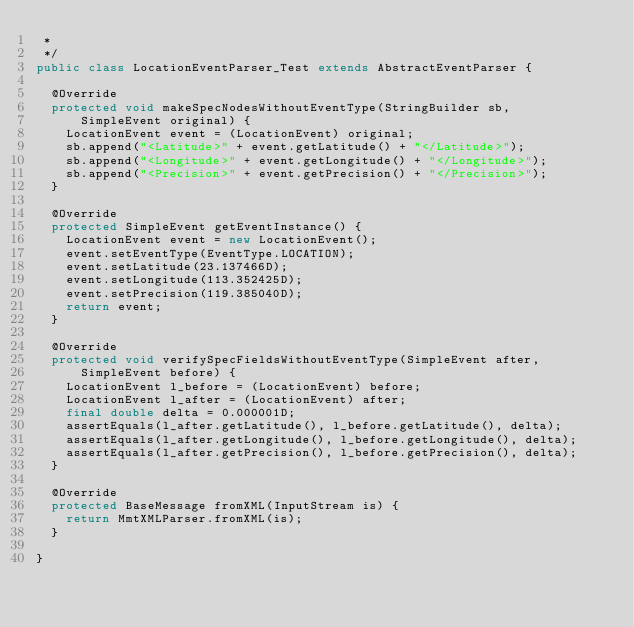<code> <loc_0><loc_0><loc_500><loc_500><_Java_> *
 */
public class LocationEventParser_Test extends AbstractEventParser {

	@Override
	protected void makeSpecNodesWithoutEventType(StringBuilder sb,
			SimpleEvent original) {
		LocationEvent event = (LocationEvent) original;
		sb.append("<Latitude>" + event.getLatitude() + "</Latitude>");
		sb.append("<Longitude>" + event.getLongitude() + "</Longitude>");
		sb.append("<Precision>" + event.getPrecision() + "</Precision>");
	}

	@Override
	protected SimpleEvent getEventInstance() {
		LocationEvent event = new LocationEvent();
		event.setEventType(EventType.LOCATION);
		event.setLatitude(23.137466D);
		event.setLongitude(113.352425D);
		event.setPrecision(119.385040D);
		return event;
	}

	@Override
	protected void verifySpecFieldsWithoutEventType(SimpleEvent after,
			SimpleEvent before) {
		LocationEvent l_before = (LocationEvent) before;
		LocationEvent l_after = (LocationEvent) after;
		final double delta = 0.000001D;
		assertEquals(l_after.getLatitude(), l_before.getLatitude(), delta);
		assertEquals(l_after.getLongitude(), l_before.getLongitude(), delta);
		assertEquals(l_after.getPrecision(), l_before.getPrecision(), delta);
	}

	@Override
	protected BaseMessage fromXML(InputStream is) {
		return MmtXMLParser.fromXML(is);
	}

}
</code> 